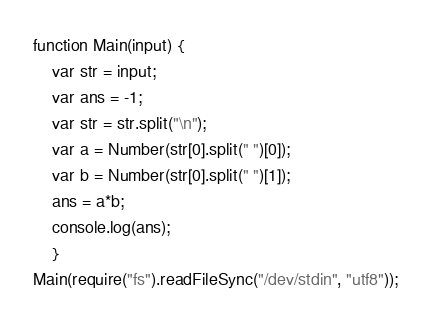<code> <loc_0><loc_0><loc_500><loc_500><_JavaScript_>function Main(input) {
	var str = input;
	var ans = -1;
	var str = str.split("\n");
	var a = Number(str[0].split(" ")[0]);
	var b = Number(str[0].split(" ")[1]);
	ans = a*b;
	console.log(ans);
	}
Main(require("fs").readFileSync("/dev/stdin", "utf8"));</code> 